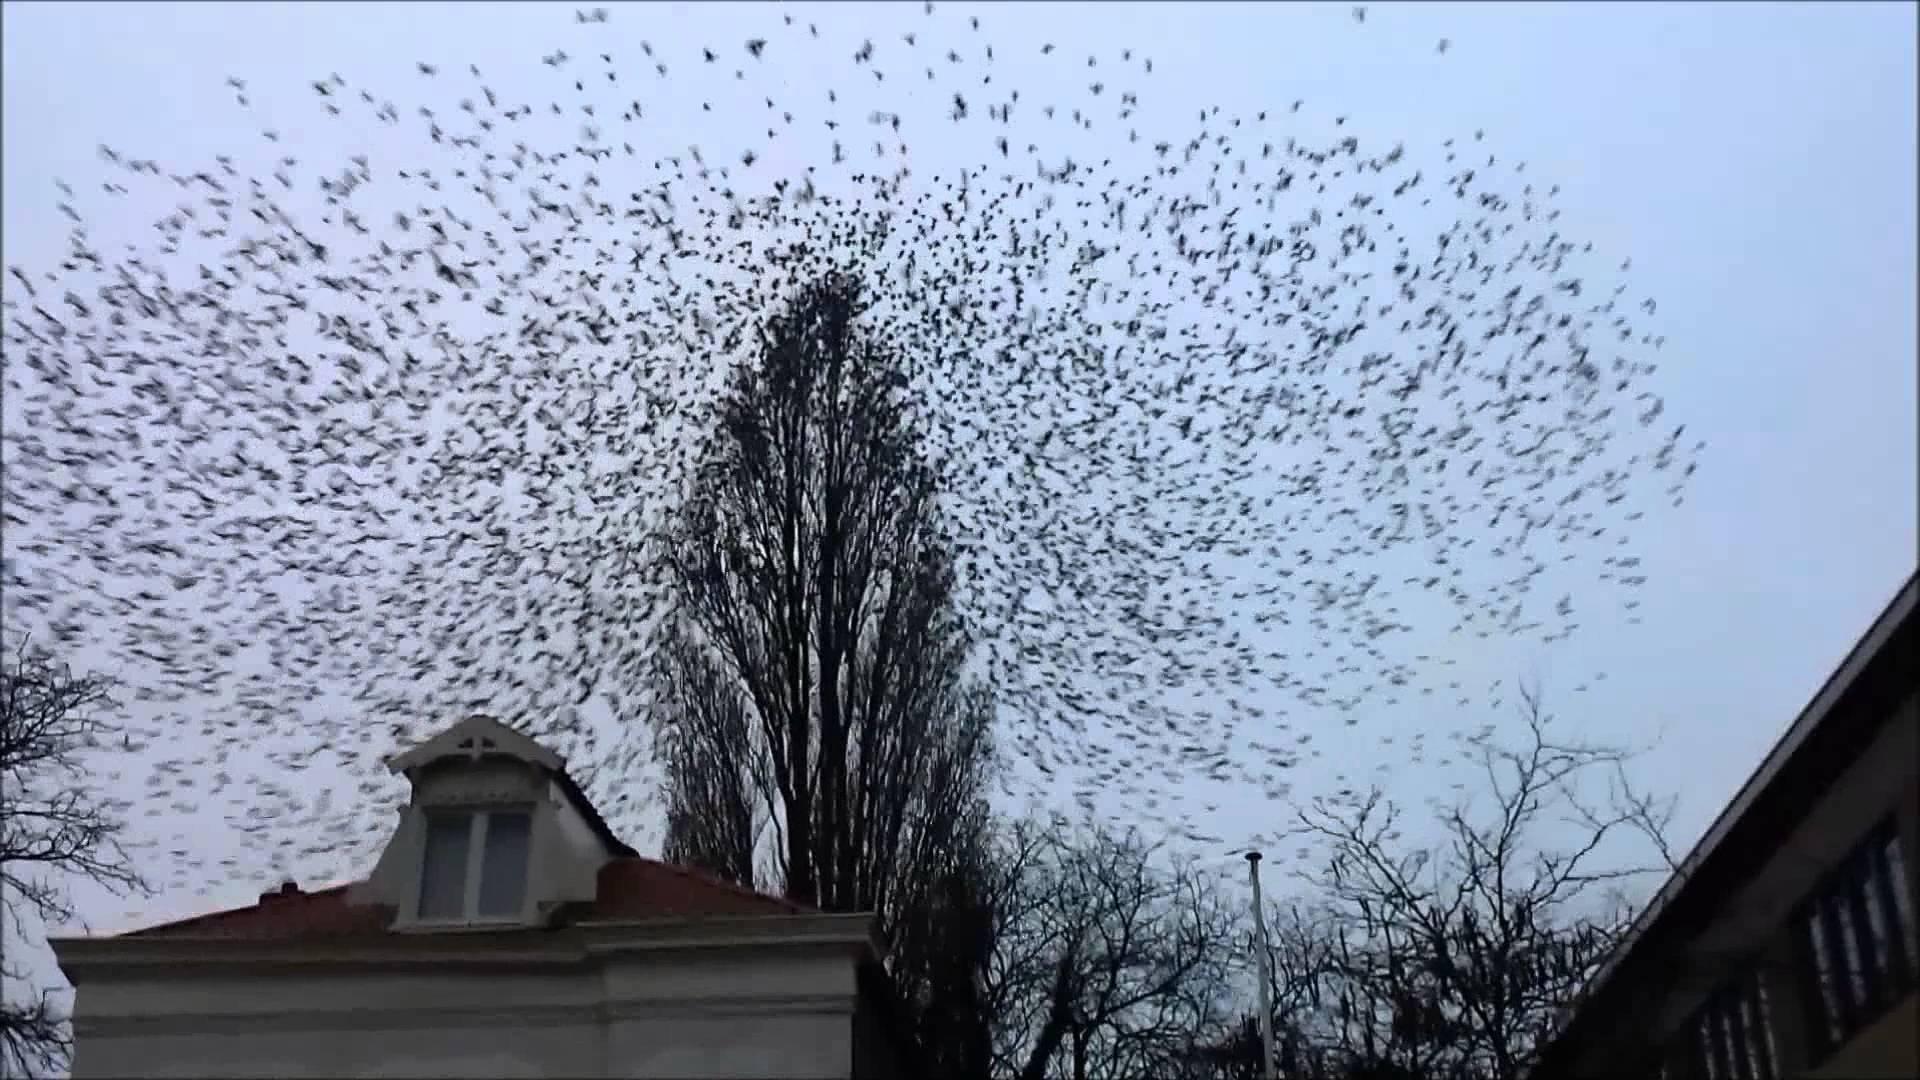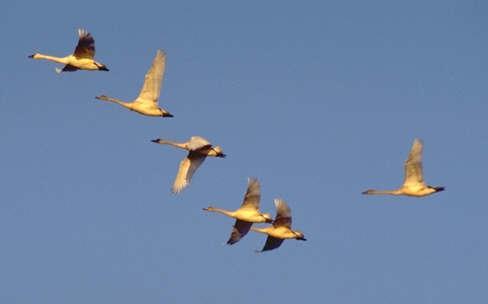The first image is the image on the left, the second image is the image on the right. Evaluate the accuracy of this statement regarding the images: "There are many more than 40 birds in total.". Is it true? Answer yes or no. Yes. 